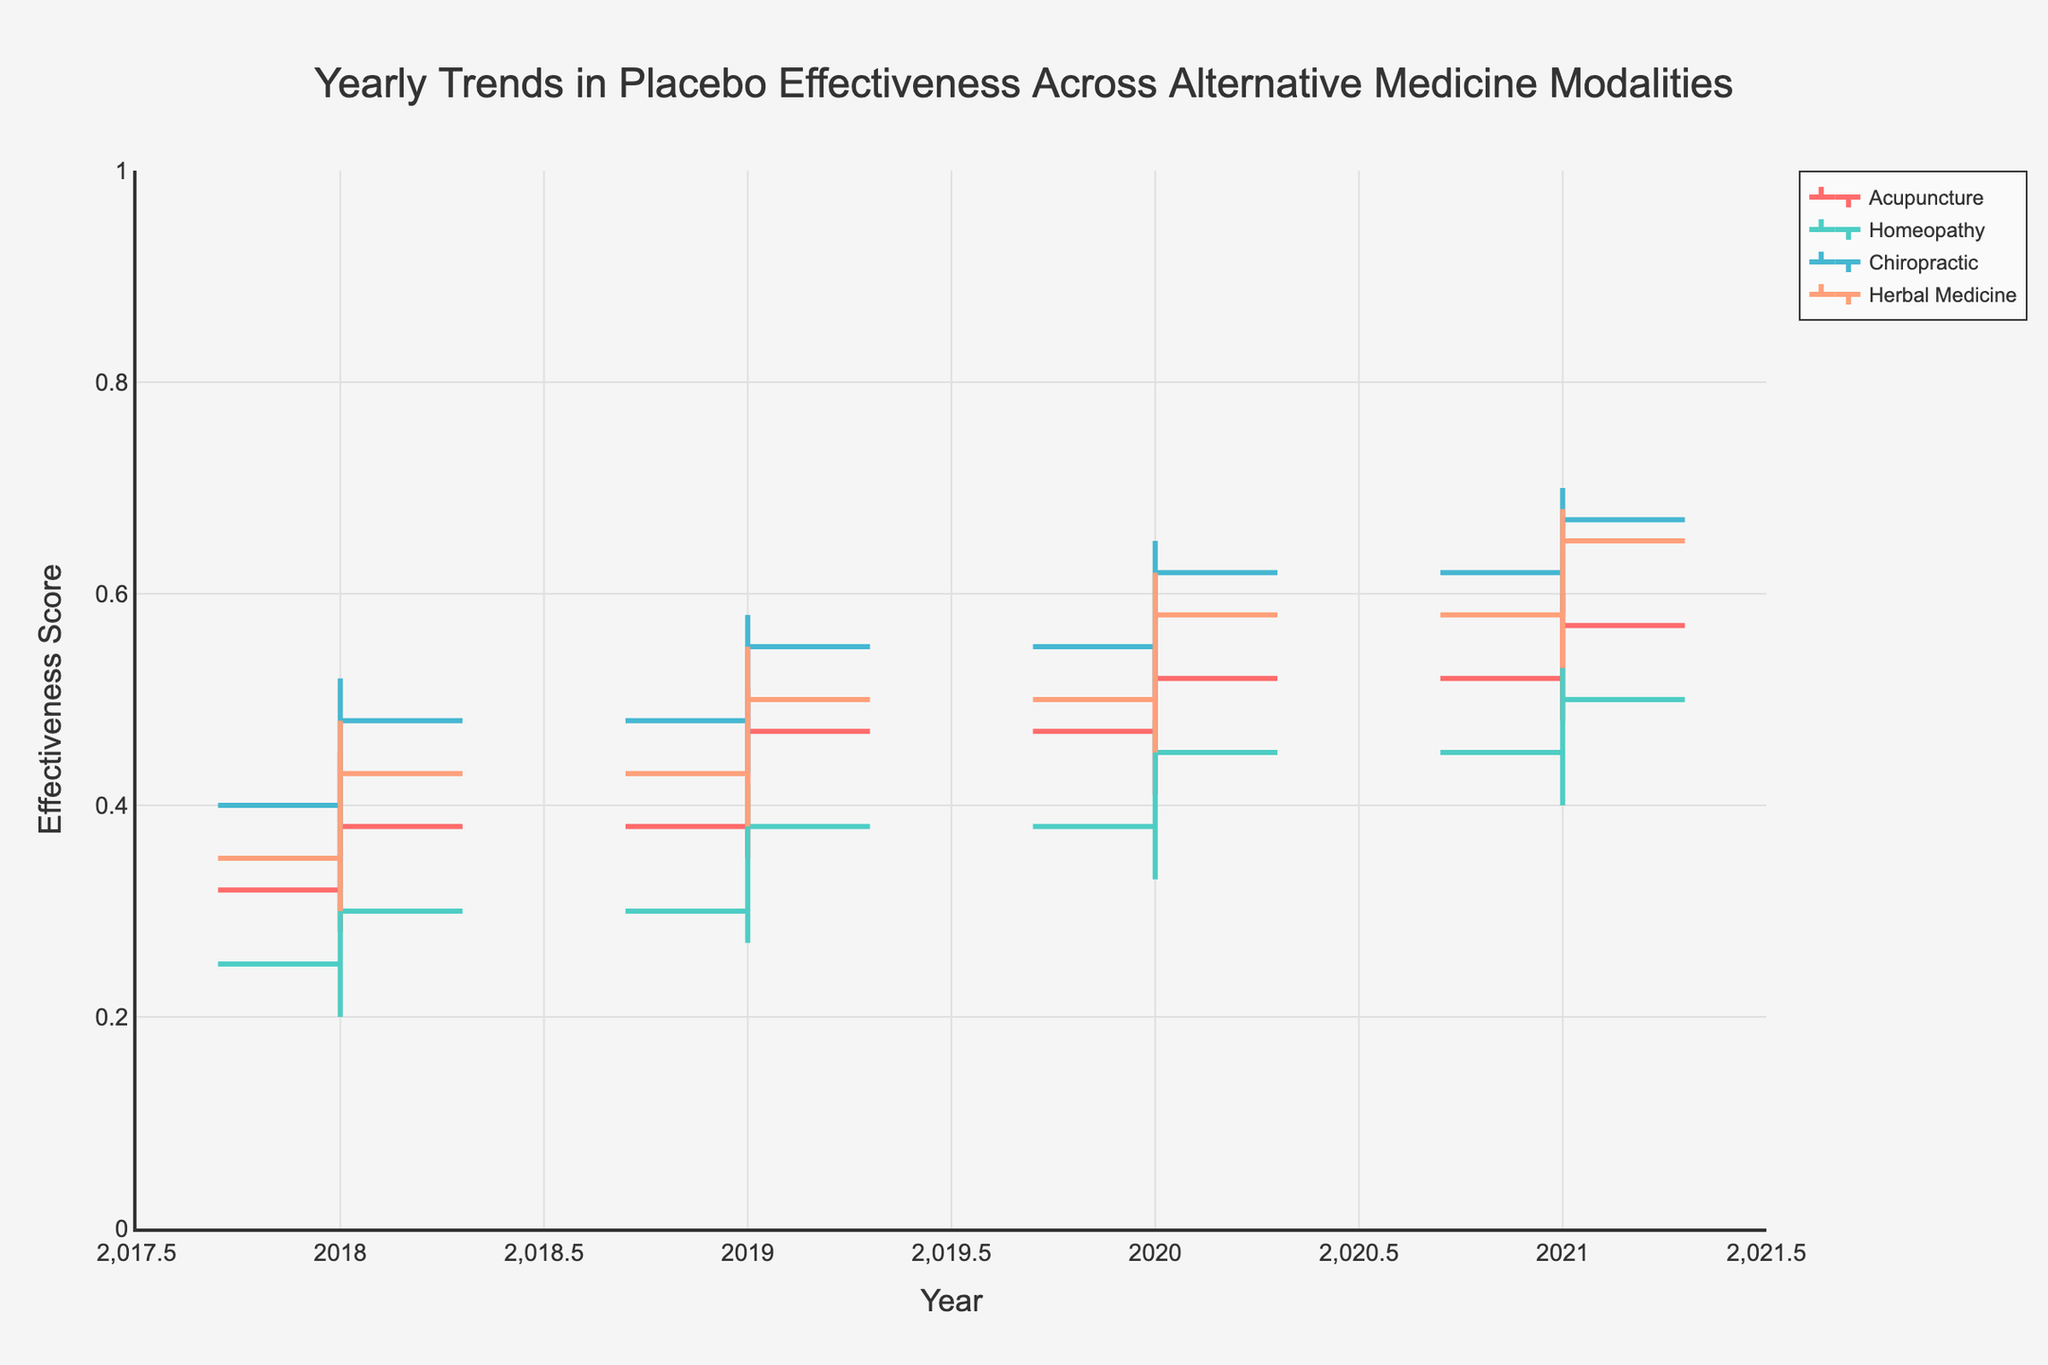What is the title of the figure? The title is located at the top of the figure and reads 'Yearly Trends in Placebo Effectiveness Across Alternative Medicine Modalities'.
Answer: Yearly Trends in Placebo Effectiveness Across Alternative Medicine Modalities What is the y-axis title? The y-axis title is labeled 'Effectiveness Score', which is located on the vertical axis of the figure.
Answer: Effectiveness Score How does the final effectiveness score for Acupuncture change from 2018 to 2021? The effectiveness score for Acupuncture can be traced by observing the 'Close' values for each year. In 2018, the score is 0.38. In 2021, it is 0.57. The change is 0.57 - 0.38 = 0.19.
Answer: 0.19 Which modality had the highest closing effectiveness score in 2021? To find the highest closing effectiveness score in 2021, we look at the 'Close' values for each modality in that year. Chiropractic has the highest score at 0.67.
Answer: Chiropractic How many different modalities are shown in the figure? Each unique color represents a different modality, and there are distinct sections for each modality. The figure includes Acupuncture, Homeopathy, Chiropractic, and Herbal Medicine. Thus, there are 4 different modalities.
Answer: 4 What is the average closing effectiveness score for Homeopathy from 2018 to 2021? Sum the closing effectiveness scores for Homeopathy for each year: 0.30 (2018) + 0.38 (2019) + 0.45 (2020) + 0.50 (2021). The total is 1.63. To find the average: 1.63 / 4 = 0.4075.
Answer: 0.4075 Which modality shows an increase in effectiveness score every year from 2018 to 2021? By examining the 'Close' values, we see that for Acupuncture, Chiropractic, and Herbal Medicine, the scores increase each year without any decrease. Each of these shows a consistent yearly increase.
Answer: Acupuncture, Chiropractic, Herbal Medicine What is the difference between the highest and lowest effectiveness scores for Chiropractic in 2020? For Chiropractic in 2020, the highest score (High) is 0.65 and the lowest score (Low) is 0.50. The difference is 0.65 - 0.50 = 0.15.
Answer: 0.15 Did any modality experience a decrease in the effectiveness score in any year from 2018 to 2021? By observing the 'Close' values for each year across all modalities, none of the modalities show a decrease in the closing effectiveness score for any year from 2018 to 2021. Each score either remains the same or increases year-to-year.
Answer: No 